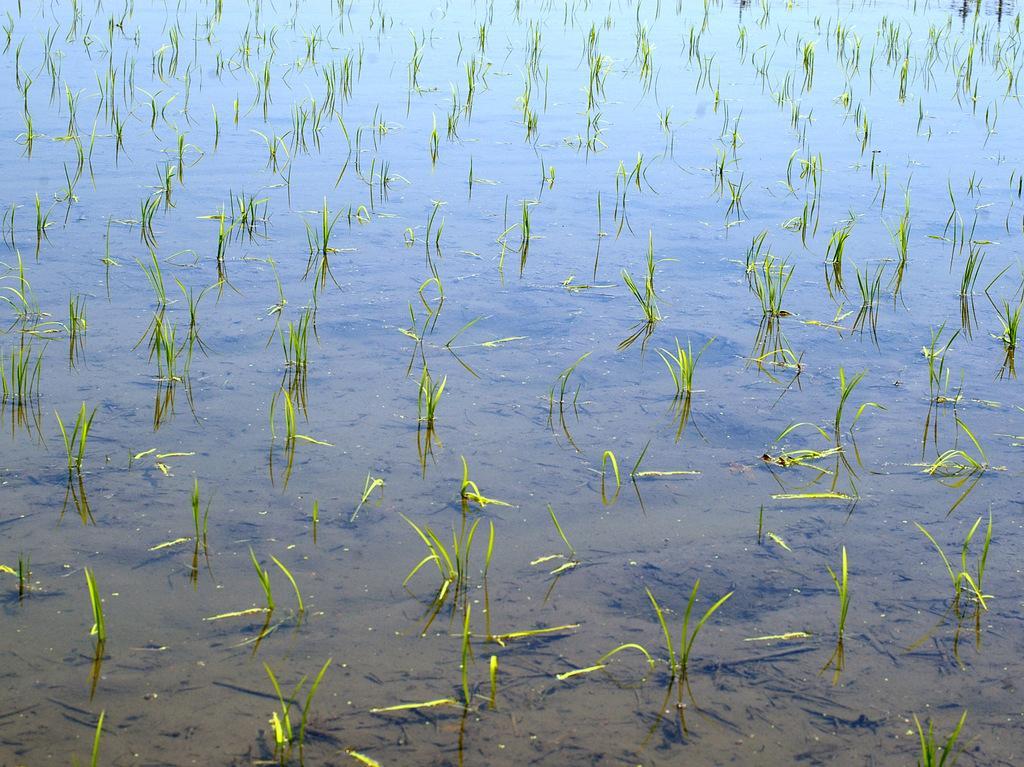Could you give a brief overview of what you see in this image? In this image I see the water and I see the soil which is of brown in color and I see the green grass. 